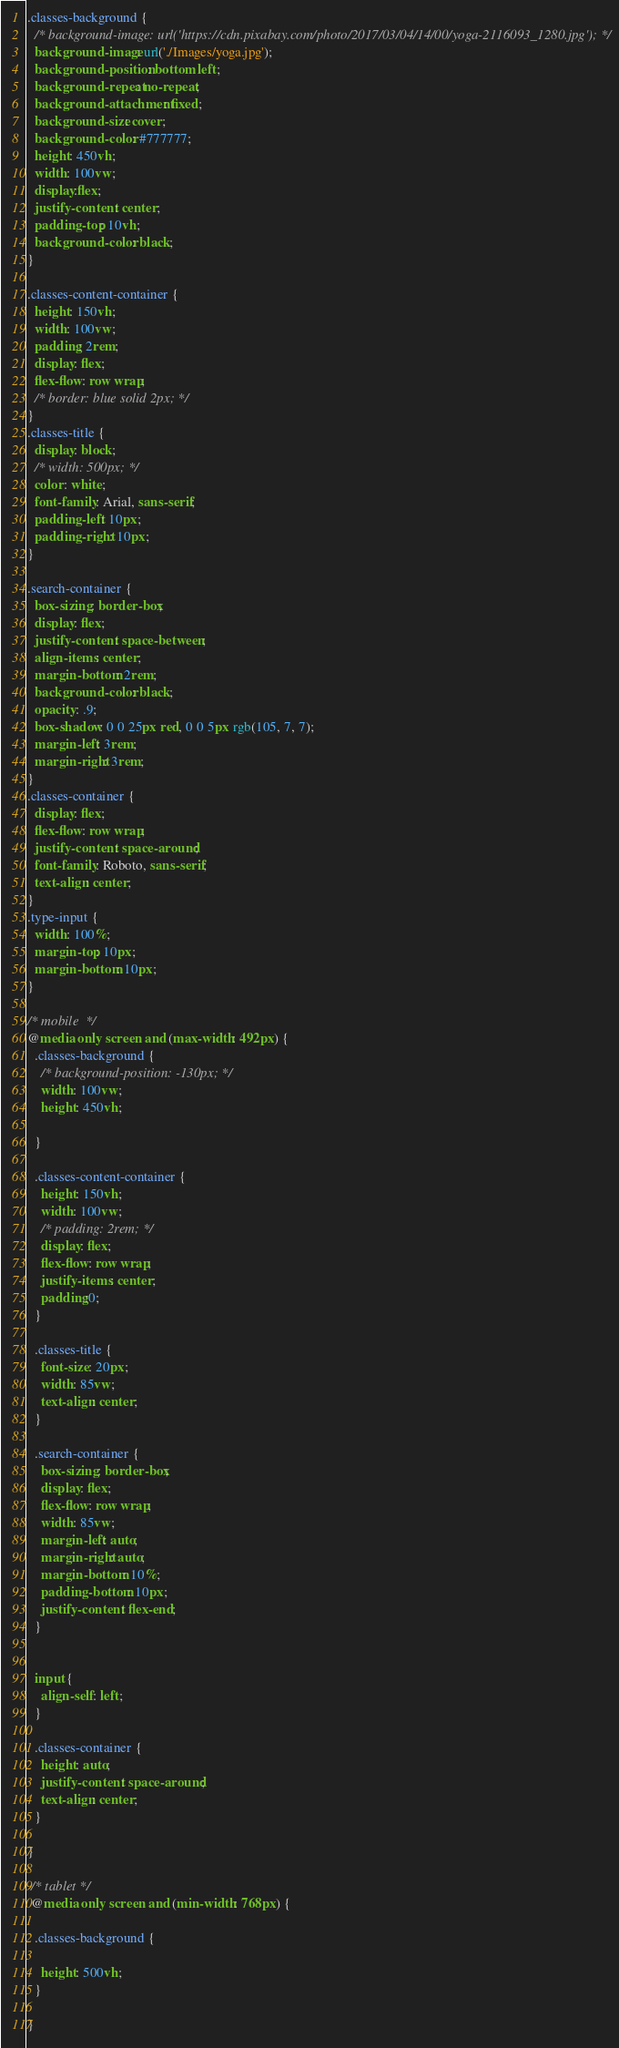Convert code to text. <code><loc_0><loc_0><loc_500><loc_500><_CSS_>.classes-background {
  /* background-image: url('https://cdn.pixabay.com/photo/2017/03/04/14/00/yoga-2116093_1280.jpg'); */
  background-image: url('./Images/yoga.jpg');
  background-position: bottom left;
  background-repeat: no-repeat;
  background-attachment: fixed;
  background-size: cover;
  background-color: #777777;
  height: 450vh;
  width: 100vw;
  display:flex;
  justify-content: center;
  padding-top: 10vh;
  background-color: black;
}

.classes-content-container {
  height: 150vh;
  width: 100vw;
  padding: 2rem;
  display: flex;
  flex-flow: row wrap;
  /* border: blue solid 2px; */
}
.classes-title {
  display: block;
  /* width: 500px; */
  color: white;
  font-family: Arial, sans-serif;
  padding-left: 10px;
  padding-right: 10px;
}

.search-container {
  box-sizing: border-box;
  display: flex;
  justify-content: space-between;
  align-items: center;
  margin-bottom: 2rem;
  background-color: black;
  opacity: .9;
  box-shadow: 0 0 25px red, 0 0 5px rgb(105, 7, 7);
  margin-left: 3rem;
  margin-right: 3rem;
}
.classes-container {
  display: flex;
  flex-flow: row wrap;
  justify-content: space-around;
  font-family: Roboto, sans-serif;
  text-align: center;
}
.type-input {
  width: 100%;
  margin-top: 10px;
  margin-bottom: 10px;
}

/* mobile  */
@media only screen and (max-width: 492px) {
  .classes-background {
    /* background-position: -130px; */
    width: 100vw;
    height: 450vh;

  }

  .classes-content-container {
    height: 150vh;
    width: 100vw;
    /* padding: 2rem; */
    display: flex;
    flex-flow: row wrap;
    justify-items: center;
    padding:0;
  }

  .classes-title {
    font-size: 20px;
    width: 85vw;
    text-align: center;
  }
  
  .search-container {
    box-sizing: border-box;
    display: flex;
    flex-flow: row wrap;
    width: 85vw;
    margin-left: auto;
    margin-right: auto;
    margin-bottom: 10%;
    padding-bottom: 10px;
    justify-content: flex-end;
  }


  input {
    align-self: left;
  }

  .classes-container {
    height: auto;
    justify-content: space-around;
    text-align: center;
  }

}

 /* tablet */
 @media only screen and (min-width: 768px) {

  .classes-background {

    height: 500vh;
  }

}


</code> 